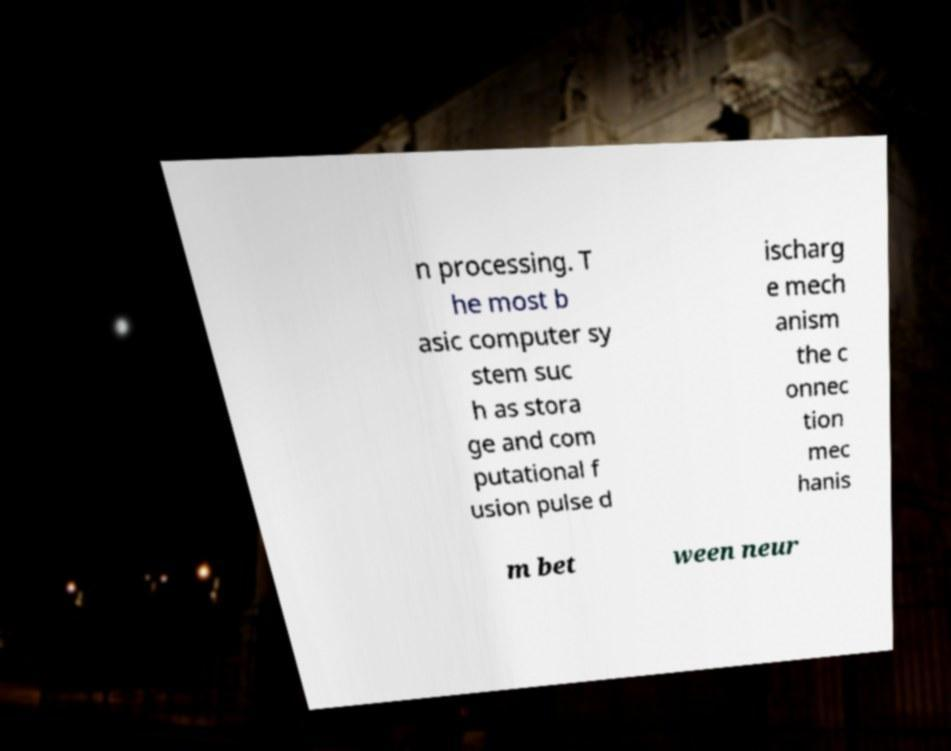Can you accurately transcribe the text from the provided image for me? n processing. T he most b asic computer sy stem suc h as stora ge and com putational f usion pulse d ischarg e mech anism the c onnec tion mec hanis m bet ween neur 